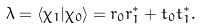Convert formula to latex. <formula><loc_0><loc_0><loc_500><loc_500>\lambda = \langle \chi _ { 1 } | \chi _ { 0 } \rangle = r _ { 0 } r _ { 1 } ^ { * } + t _ { 0 } t _ { 1 } ^ { * } .</formula> 